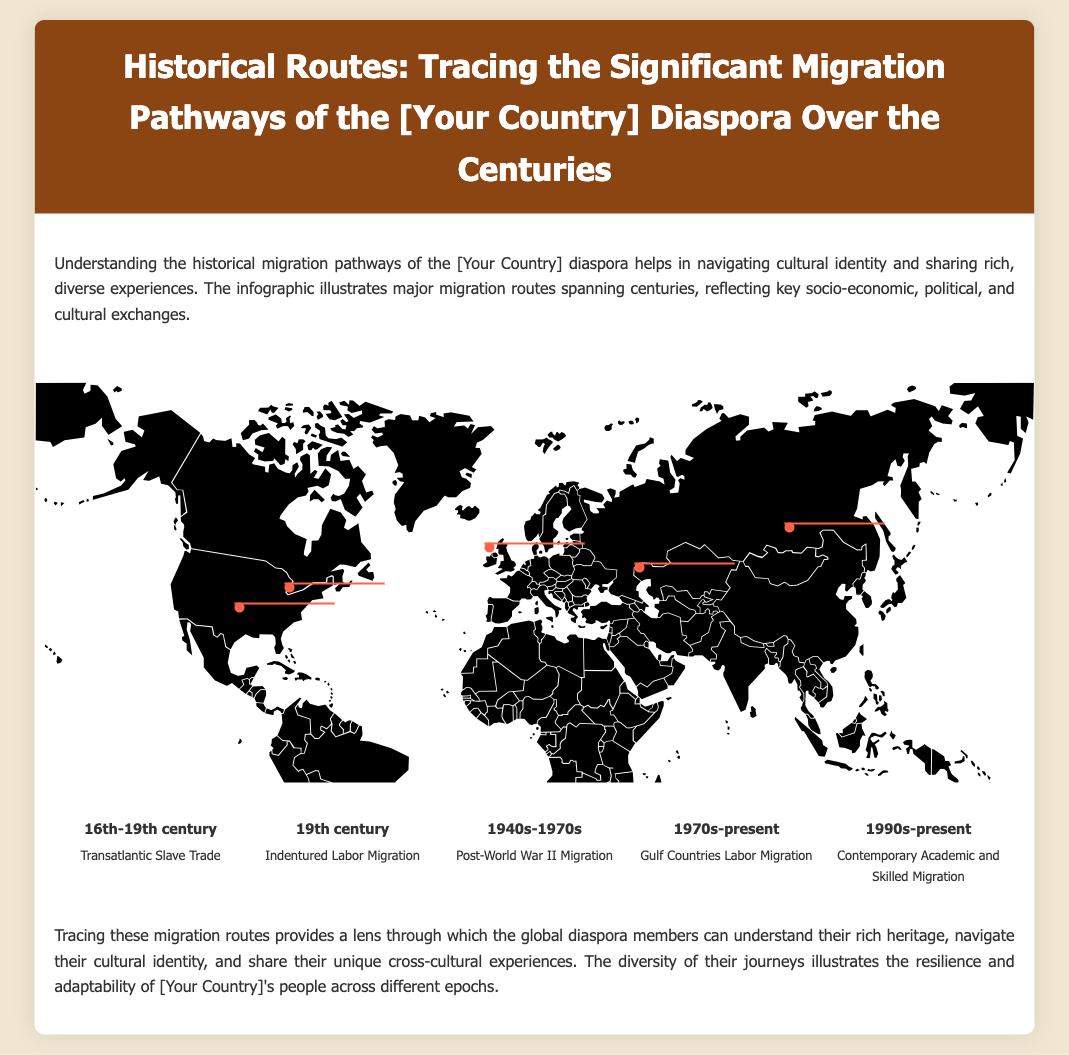what period did the Transatlantic Slave Trade occur? The document states that the Transatlantic Slave Trade took place from the 16th to 19th century.
Answer: 16th to 19th century which migration period involved indentured labor? The document specifies that Indentured Labor Migration happened during the 19th century.
Answer: 19th century what major migration occurred from the 1940s to 1970s? The document mentions Post-World War II Migration for that period.
Answer: Post-World War II Migration what was a significant driving force for migration to Gulf countries? The document indicates that economic opportunities drove [Your Country] workers to Gulf countries.
Answer: Economic opportunities what is the current trend of migration highlighted in the infographic? The document reveals that contemporary academic and skilled migration is increasing.
Answer: Contemporary academic and skilled migration how many major migration routes are illustrated in the infographic? The document shows five major migration routes of the [Your Country] diaspora.
Answer: Five what type of document is this? The document is a geographic infographic detailing the migration pathways of the [Your Country] diaspora.
Answer: Geographic infographic what color represents the migration routes on the map? The migration routes are represented in red (tomato).
Answer: Red (tomato) 